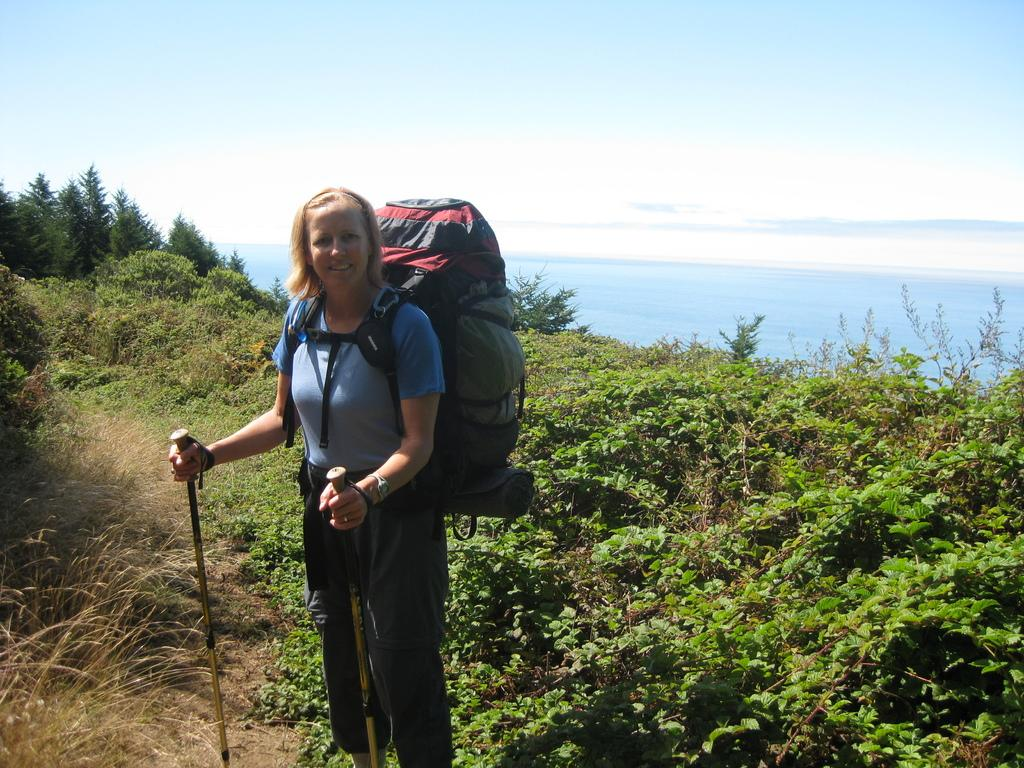What is the lady in the image holding? The lady is holding a stick. What accessories is the lady wearing? The lady is wearing a watch and a bag. What is the lady's posture in the image? The lady is standing. What can be seen near the lady in the image? There are many plants near the lady. What is visible in the background of the image? Water, sky, and trees are visible in the background. What type of sand can be seen near the lady in the image? There is no sand visible in the image; instead, there are many plants near the lady. 